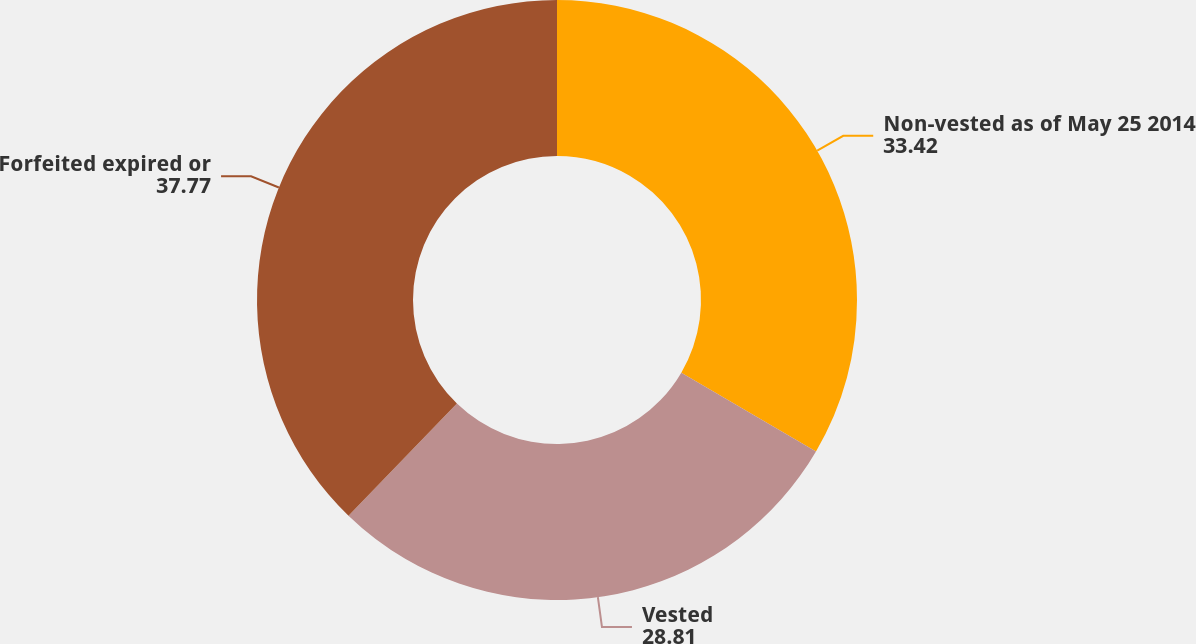Convert chart. <chart><loc_0><loc_0><loc_500><loc_500><pie_chart><fcel>Non-vested as of May 25 2014<fcel>Vested<fcel>Forfeited expired or<nl><fcel>33.42%<fcel>28.81%<fcel>37.77%<nl></chart> 